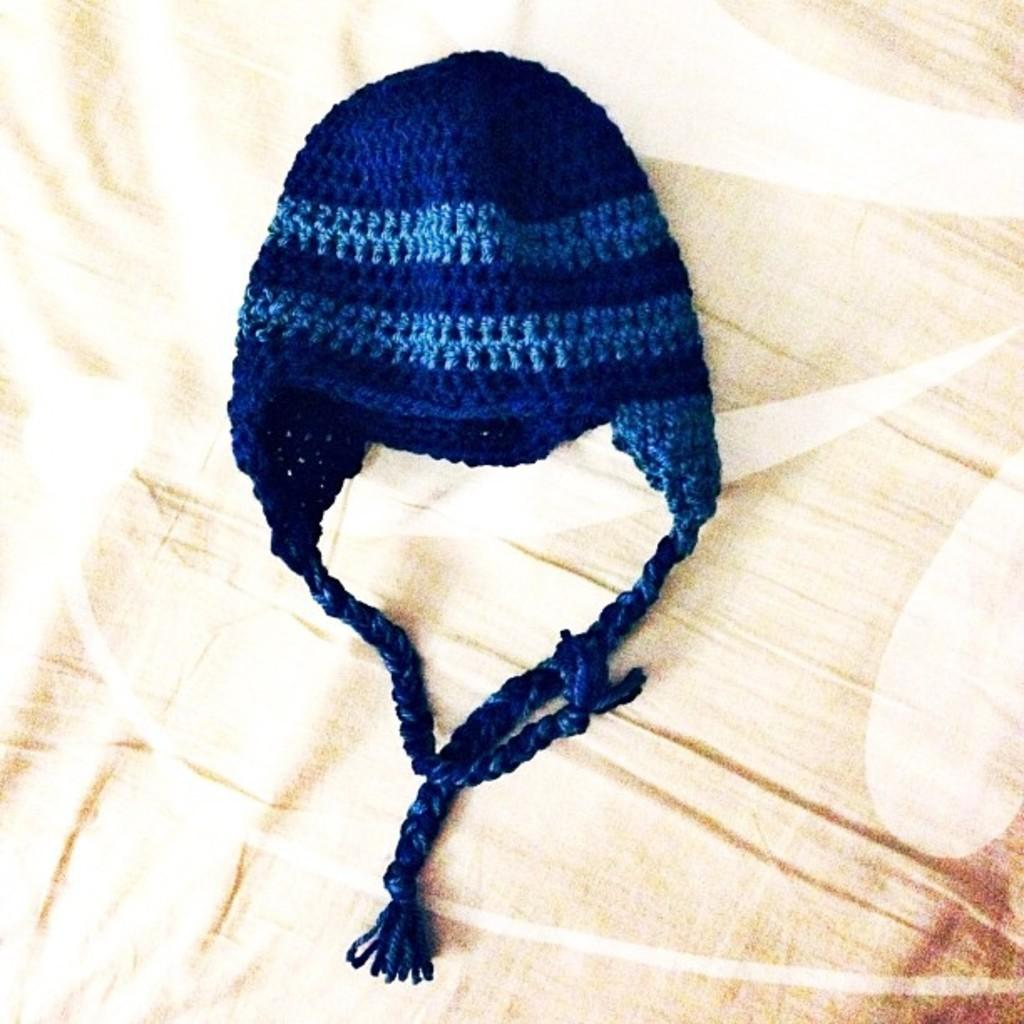What type of clothing item is visible in the image? There is a knit cap in the image. Can you describe the background of the image? There is a cloth truncated in the background of the image. What type of sock is visible on the person's foot in the image? There is no sock visible in the image; only a knit cap is present. How many buttons can be seen on the knit cap in the image? There are no buttons visible on the knit cap in the image. 